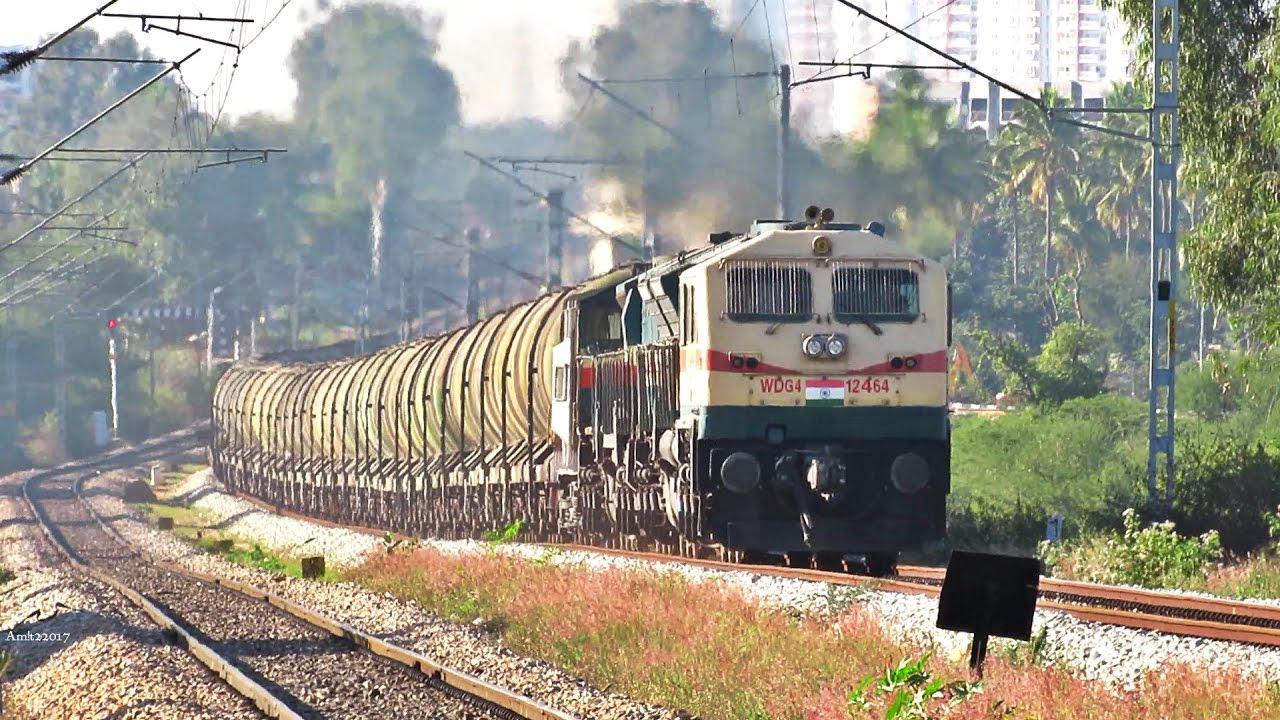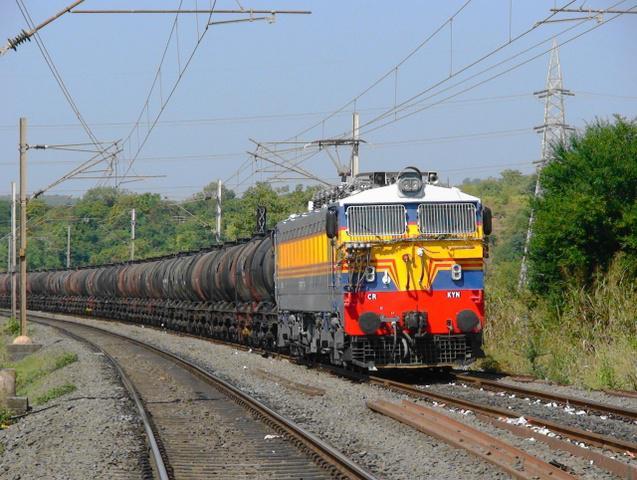The first image is the image on the left, the second image is the image on the right. For the images shown, is this caption "Right image shows a green train moving in a rightward direction." true? Answer yes or no. No. 